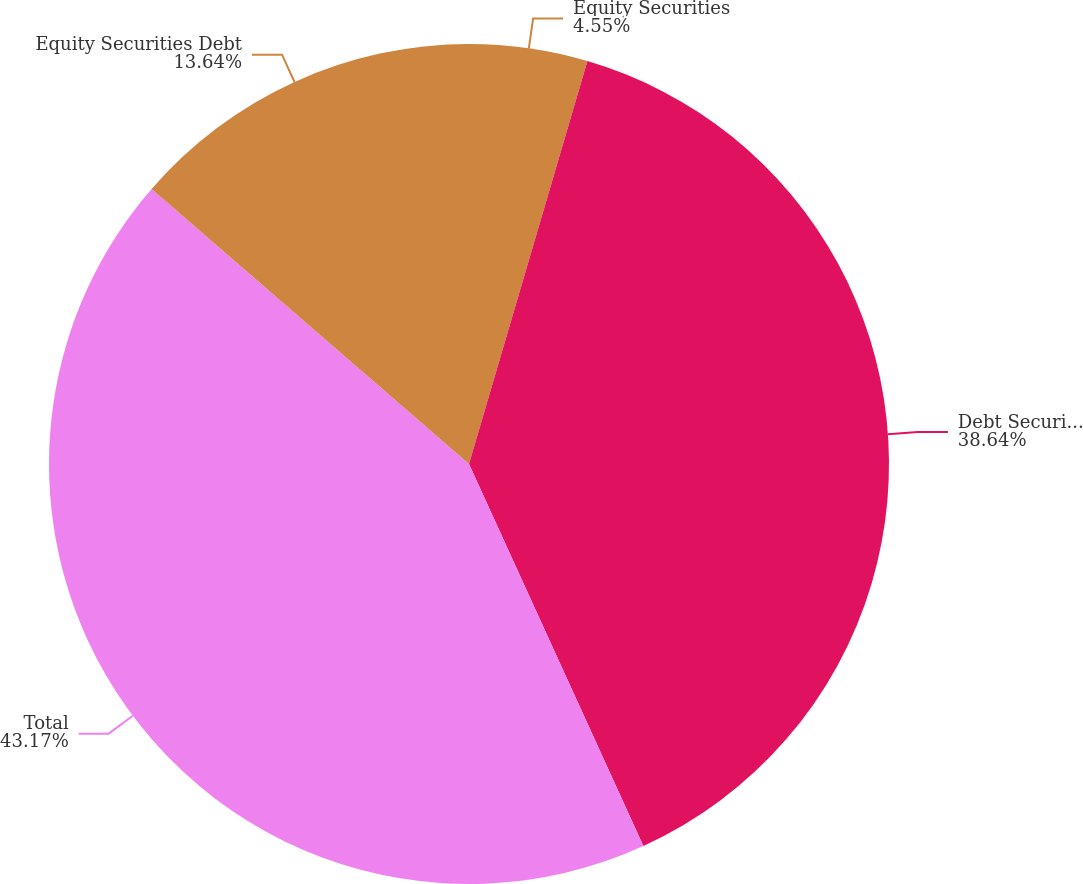Convert chart to OTSL. <chart><loc_0><loc_0><loc_500><loc_500><pie_chart><fcel>Equity Securities<fcel>Debt Securities<fcel>Total<fcel>Equity Securities Debt<nl><fcel>4.55%<fcel>38.64%<fcel>43.18%<fcel>13.64%<nl></chart> 